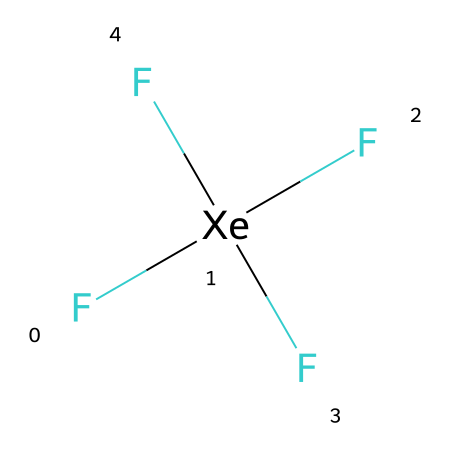What is the molecular formula of xenon tetrafluoride? The chemical is represented by the given SMILES notation F[Xe](F)(F)F, which indicates that it consists of one xenon atom and four fluorine atoms. Therefore, the molecular formula can be directly derived from this structure.
Answer: XeF4 How many bonds does xenon tetrafluoride have? In the structure of xenon tetrafluoride, each fluorine atom is bonded to the xenon atom. There are a total of four fluorine atoms, meaning there are four single bonds connecting fluorine to xenon. Thus, the total number of bonds is four.
Answer: 4 What type of compound is xenon tetrafluoride categorized as? Xenon tetrafluoride has a structure where the central xenon atom is bonded to more than four atoms. This characteristic of having more than eight electrons in its valence shell makes it a hypervalent compound.
Answer: hypervalent What are the types of atoms present in xenon tetrafluoride? The molecule contains xenon and fluorine atoms, indicated by the symbols Xe and F in the SMILES notation, where Xe is the central atom and F represents the four fluorine atoms surrounding it.
Answer: xenon and fluorine Explain why xenon tetrafluoride is a stable hypervalent compound. Xenon tetrafluoride is stable due to the presence of strong covalent bonds between the xenon and fluorine atoms, as well as the octet rule being satisfied for the fluorine atoms while allowing xenon to exceed the octet rule. This stability is further supported by the absence of lone pairs on the central xenon atom, leading to a stable electronic arrangement.
Answer: strong covalent bonds How does the structure of xenon tetrafluoride relate to its applications in advanced technologies? Xenon tetrafluoride's hypervalent nature allows for unique molecular interactions; it can act as a powerful fluorinating agent, which is useful in the design of advanced materials and encryption technologies through the development of specialized chemical processes.
Answer: unique molecular interactions 